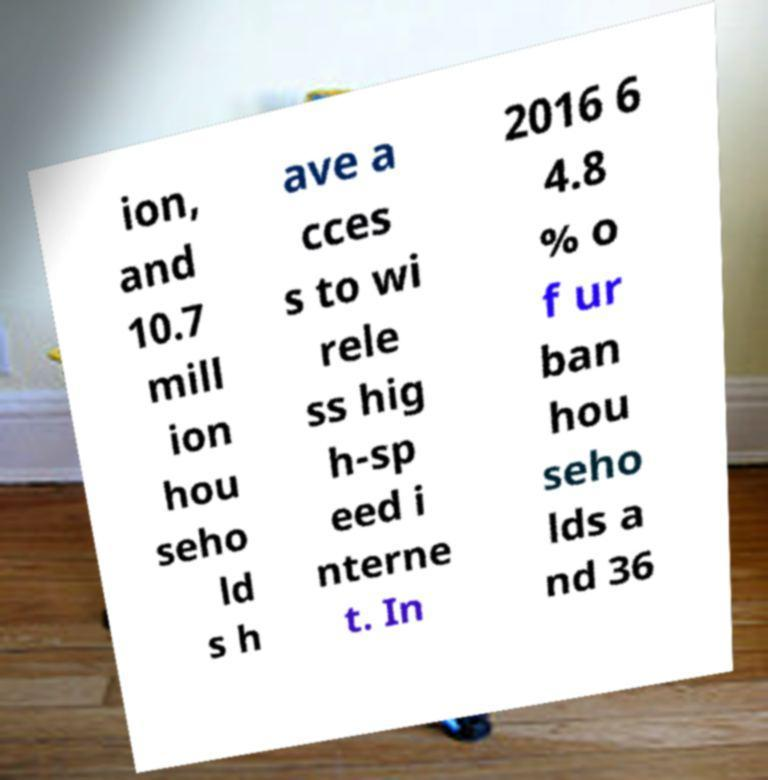What messages or text are displayed in this image? I need them in a readable, typed format. ion, and 10.7 mill ion hou seho ld s h ave a cces s to wi rele ss hig h-sp eed i nterne t. In 2016 6 4.8 % o f ur ban hou seho lds a nd 36 